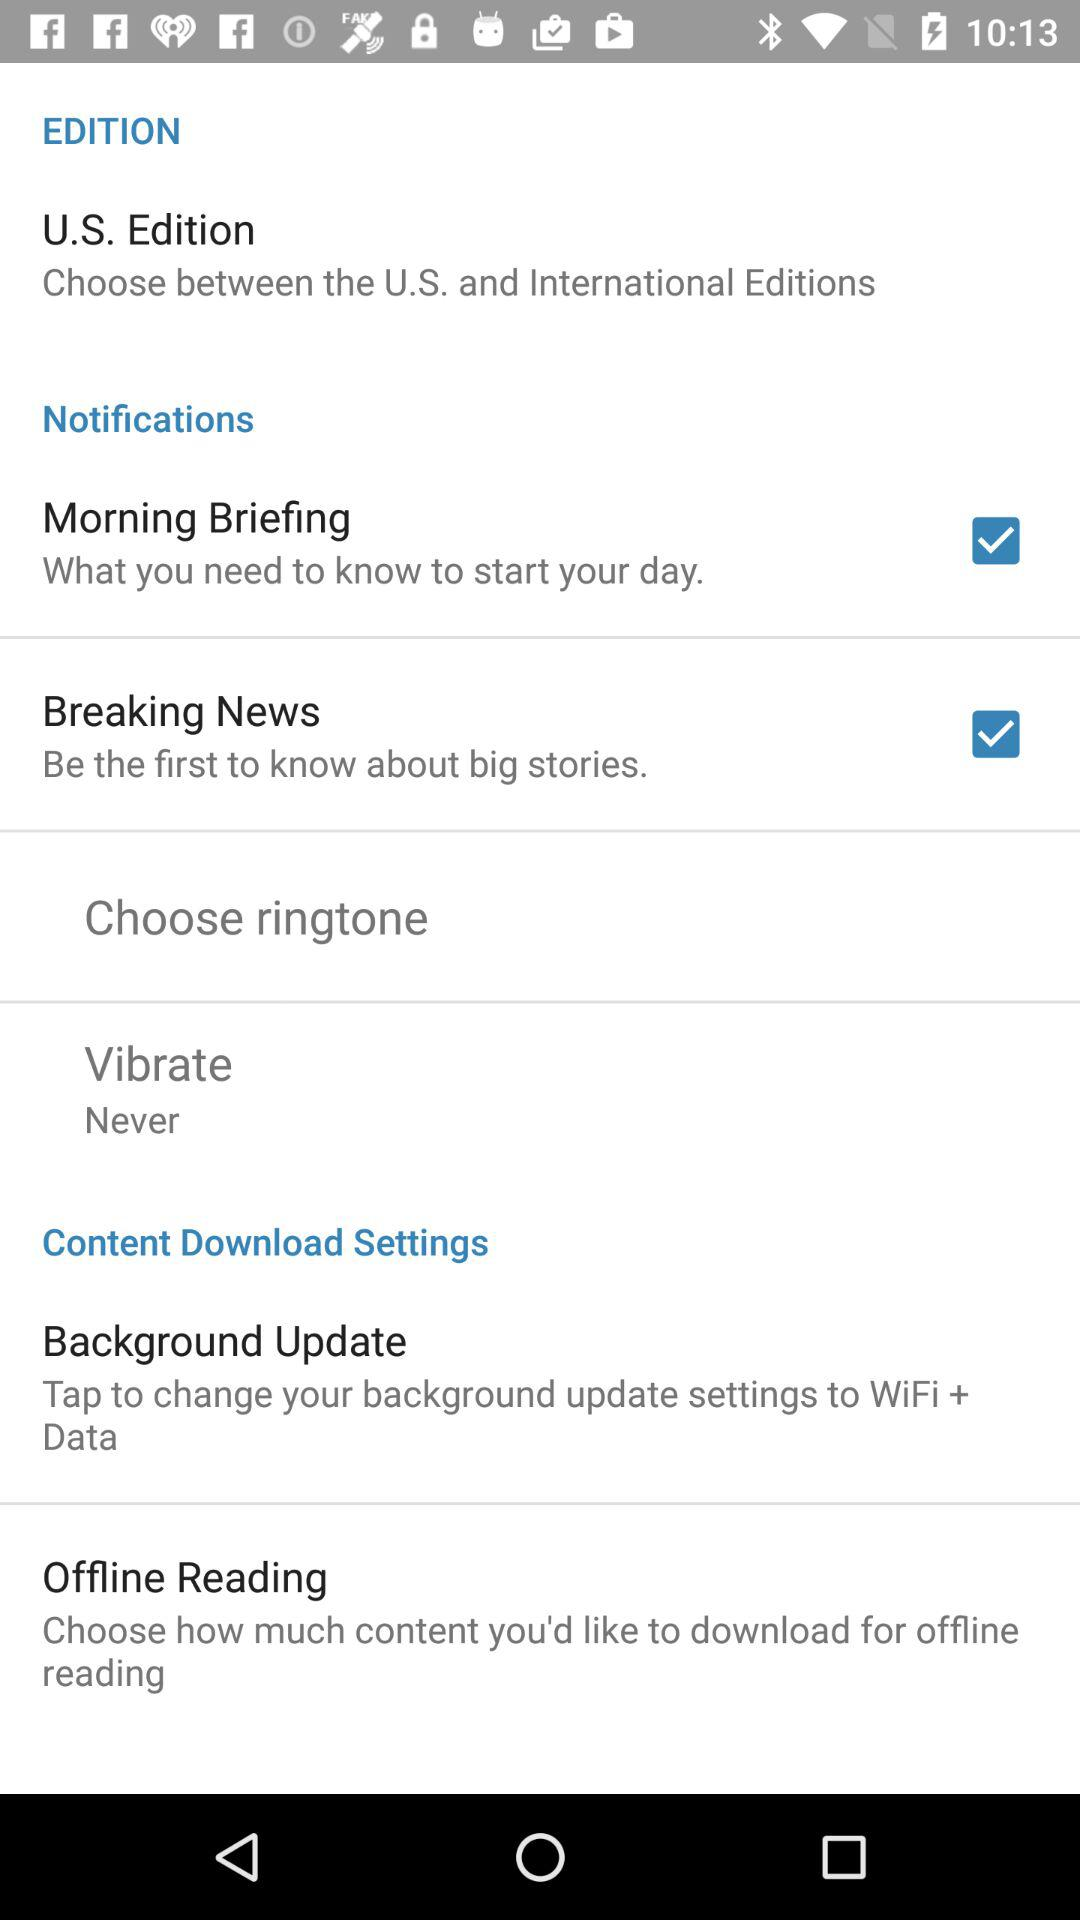How many items in the 'Notifications' section have a checkbox?
Answer the question using a single word or phrase. 2 